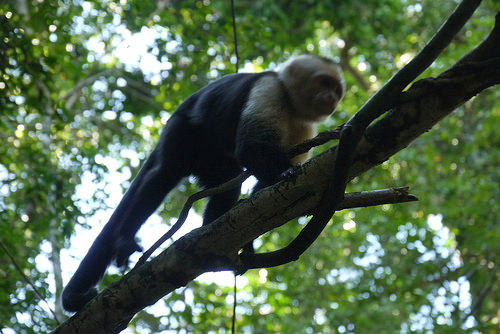<image>
Is the leaf above the monkey? Yes. The leaf is positioned above the monkey in the vertical space, higher up in the scene. 